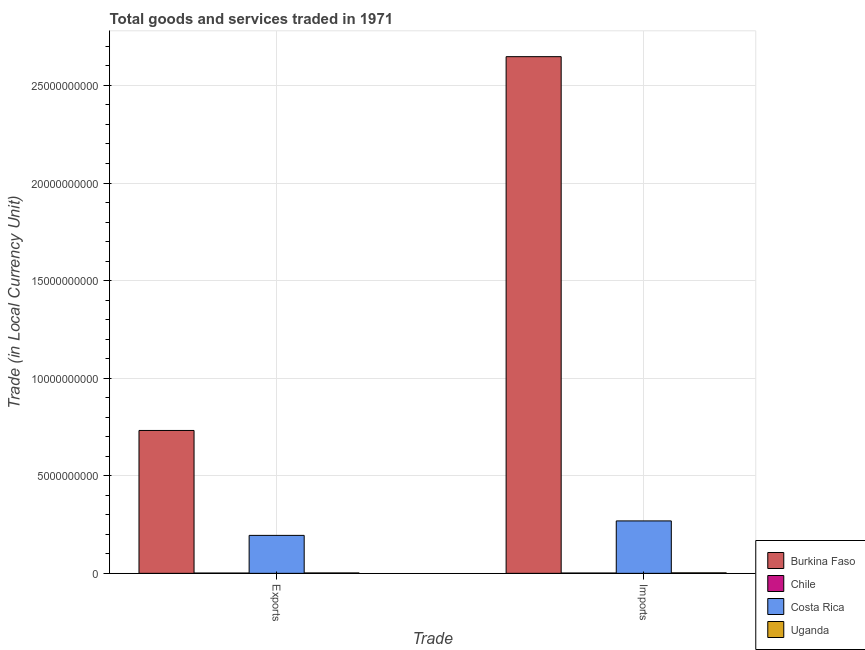How many groups of bars are there?
Provide a succinct answer. 2. Are the number of bars per tick equal to the number of legend labels?
Offer a very short reply. Yes. What is the label of the 1st group of bars from the left?
Make the answer very short. Exports. What is the export of goods and services in Chile?
Your response must be concise. 1.44e+07. Across all countries, what is the maximum imports of goods and services?
Offer a terse response. 2.65e+1. Across all countries, what is the minimum imports of goods and services?
Offer a very short reply. 1.57e+07. In which country was the imports of goods and services maximum?
Offer a terse response. Burkina Faso. In which country was the export of goods and services minimum?
Give a very brief answer. Chile. What is the total imports of goods and services in the graph?
Make the answer very short. 2.92e+1. What is the difference between the imports of goods and services in Chile and that in Costa Rica?
Make the answer very short. -2.67e+09. What is the difference between the imports of goods and services in Burkina Faso and the export of goods and services in Costa Rica?
Provide a short and direct response. 2.45e+1. What is the average imports of goods and services per country?
Give a very brief answer. 7.30e+09. What is the difference between the export of goods and services and imports of goods and services in Costa Rica?
Provide a short and direct response. -7.41e+08. What is the ratio of the export of goods and services in Costa Rica to that in Chile?
Provide a succinct answer. 135.07. In how many countries, is the imports of goods and services greater than the average imports of goods and services taken over all countries?
Your answer should be compact. 1. What does the 2nd bar from the left in Imports represents?
Your response must be concise. Chile. What does the 4th bar from the right in Exports represents?
Provide a succinct answer. Burkina Faso. Does the graph contain any zero values?
Give a very brief answer. No. How many legend labels are there?
Provide a short and direct response. 4. How are the legend labels stacked?
Keep it short and to the point. Vertical. What is the title of the graph?
Ensure brevity in your answer.  Total goods and services traded in 1971. Does "Lao PDR" appear as one of the legend labels in the graph?
Provide a short and direct response. No. What is the label or title of the X-axis?
Give a very brief answer. Trade. What is the label or title of the Y-axis?
Provide a succinct answer. Trade (in Local Currency Unit). What is the Trade (in Local Currency Unit) in Burkina Faso in Exports?
Make the answer very short. 7.32e+09. What is the Trade (in Local Currency Unit) in Chile in Exports?
Ensure brevity in your answer.  1.44e+07. What is the Trade (in Local Currency Unit) of Costa Rica in Exports?
Ensure brevity in your answer.  1.94e+09. What is the Trade (in Local Currency Unit) in Uganda in Exports?
Your answer should be compact. 2.01e+07. What is the Trade (in Local Currency Unit) of Burkina Faso in Imports?
Ensure brevity in your answer.  2.65e+1. What is the Trade (in Local Currency Unit) in Chile in Imports?
Provide a succinct answer. 1.57e+07. What is the Trade (in Local Currency Unit) in Costa Rica in Imports?
Offer a terse response. 2.69e+09. What is the Trade (in Local Currency Unit) of Uganda in Imports?
Ensure brevity in your answer.  2.42e+07. Across all Trade, what is the maximum Trade (in Local Currency Unit) of Burkina Faso?
Your response must be concise. 2.65e+1. Across all Trade, what is the maximum Trade (in Local Currency Unit) in Chile?
Offer a terse response. 1.57e+07. Across all Trade, what is the maximum Trade (in Local Currency Unit) of Costa Rica?
Your answer should be very brief. 2.69e+09. Across all Trade, what is the maximum Trade (in Local Currency Unit) of Uganda?
Make the answer very short. 2.42e+07. Across all Trade, what is the minimum Trade (in Local Currency Unit) of Burkina Faso?
Ensure brevity in your answer.  7.32e+09. Across all Trade, what is the minimum Trade (in Local Currency Unit) of Chile?
Your answer should be compact. 1.44e+07. Across all Trade, what is the minimum Trade (in Local Currency Unit) of Costa Rica?
Your answer should be compact. 1.94e+09. Across all Trade, what is the minimum Trade (in Local Currency Unit) of Uganda?
Give a very brief answer. 2.01e+07. What is the total Trade (in Local Currency Unit) in Burkina Faso in the graph?
Your answer should be very brief. 3.38e+1. What is the total Trade (in Local Currency Unit) in Chile in the graph?
Give a very brief answer. 3.01e+07. What is the total Trade (in Local Currency Unit) in Costa Rica in the graph?
Offer a terse response. 4.63e+09. What is the total Trade (in Local Currency Unit) of Uganda in the graph?
Give a very brief answer. 4.43e+07. What is the difference between the Trade (in Local Currency Unit) in Burkina Faso in Exports and that in Imports?
Ensure brevity in your answer.  -1.92e+1. What is the difference between the Trade (in Local Currency Unit) of Chile in Exports and that in Imports?
Ensure brevity in your answer.  -1.30e+06. What is the difference between the Trade (in Local Currency Unit) of Costa Rica in Exports and that in Imports?
Your response must be concise. -7.41e+08. What is the difference between the Trade (in Local Currency Unit) of Uganda in Exports and that in Imports?
Your response must be concise. -4.19e+06. What is the difference between the Trade (in Local Currency Unit) of Burkina Faso in Exports and the Trade (in Local Currency Unit) of Chile in Imports?
Provide a short and direct response. 7.31e+09. What is the difference between the Trade (in Local Currency Unit) in Burkina Faso in Exports and the Trade (in Local Currency Unit) in Costa Rica in Imports?
Give a very brief answer. 4.63e+09. What is the difference between the Trade (in Local Currency Unit) of Burkina Faso in Exports and the Trade (in Local Currency Unit) of Uganda in Imports?
Your answer should be compact. 7.30e+09. What is the difference between the Trade (in Local Currency Unit) in Chile in Exports and the Trade (in Local Currency Unit) in Costa Rica in Imports?
Your response must be concise. -2.67e+09. What is the difference between the Trade (in Local Currency Unit) in Chile in Exports and the Trade (in Local Currency Unit) in Uganda in Imports?
Offer a very short reply. -9.85e+06. What is the difference between the Trade (in Local Currency Unit) in Costa Rica in Exports and the Trade (in Local Currency Unit) in Uganda in Imports?
Offer a very short reply. 1.92e+09. What is the average Trade (in Local Currency Unit) of Burkina Faso per Trade?
Your response must be concise. 1.69e+1. What is the average Trade (in Local Currency Unit) of Chile per Trade?
Keep it short and to the point. 1.50e+07. What is the average Trade (in Local Currency Unit) in Costa Rica per Trade?
Offer a terse response. 2.32e+09. What is the average Trade (in Local Currency Unit) of Uganda per Trade?
Offer a terse response. 2.22e+07. What is the difference between the Trade (in Local Currency Unit) in Burkina Faso and Trade (in Local Currency Unit) in Chile in Exports?
Ensure brevity in your answer.  7.31e+09. What is the difference between the Trade (in Local Currency Unit) of Burkina Faso and Trade (in Local Currency Unit) of Costa Rica in Exports?
Keep it short and to the point. 5.38e+09. What is the difference between the Trade (in Local Currency Unit) of Burkina Faso and Trade (in Local Currency Unit) of Uganda in Exports?
Your answer should be compact. 7.30e+09. What is the difference between the Trade (in Local Currency Unit) in Chile and Trade (in Local Currency Unit) in Costa Rica in Exports?
Keep it short and to the point. -1.93e+09. What is the difference between the Trade (in Local Currency Unit) of Chile and Trade (in Local Currency Unit) of Uganda in Exports?
Provide a short and direct response. -5.66e+06. What is the difference between the Trade (in Local Currency Unit) in Costa Rica and Trade (in Local Currency Unit) in Uganda in Exports?
Offer a terse response. 1.92e+09. What is the difference between the Trade (in Local Currency Unit) in Burkina Faso and Trade (in Local Currency Unit) in Chile in Imports?
Offer a terse response. 2.65e+1. What is the difference between the Trade (in Local Currency Unit) in Burkina Faso and Trade (in Local Currency Unit) in Costa Rica in Imports?
Offer a terse response. 2.38e+1. What is the difference between the Trade (in Local Currency Unit) of Burkina Faso and Trade (in Local Currency Unit) of Uganda in Imports?
Make the answer very short. 2.65e+1. What is the difference between the Trade (in Local Currency Unit) in Chile and Trade (in Local Currency Unit) in Costa Rica in Imports?
Provide a short and direct response. -2.67e+09. What is the difference between the Trade (in Local Currency Unit) of Chile and Trade (in Local Currency Unit) of Uganda in Imports?
Ensure brevity in your answer.  -8.55e+06. What is the difference between the Trade (in Local Currency Unit) of Costa Rica and Trade (in Local Currency Unit) of Uganda in Imports?
Your response must be concise. 2.66e+09. What is the ratio of the Trade (in Local Currency Unit) of Burkina Faso in Exports to that in Imports?
Your answer should be compact. 0.28. What is the ratio of the Trade (in Local Currency Unit) of Chile in Exports to that in Imports?
Offer a terse response. 0.92. What is the ratio of the Trade (in Local Currency Unit) of Costa Rica in Exports to that in Imports?
Your response must be concise. 0.72. What is the ratio of the Trade (in Local Currency Unit) of Uganda in Exports to that in Imports?
Keep it short and to the point. 0.83. What is the difference between the highest and the second highest Trade (in Local Currency Unit) in Burkina Faso?
Keep it short and to the point. 1.92e+1. What is the difference between the highest and the second highest Trade (in Local Currency Unit) in Chile?
Offer a very short reply. 1.30e+06. What is the difference between the highest and the second highest Trade (in Local Currency Unit) of Costa Rica?
Offer a terse response. 7.41e+08. What is the difference between the highest and the second highest Trade (in Local Currency Unit) in Uganda?
Provide a succinct answer. 4.19e+06. What is the difference between the highest and the lowest Trade (in Local Currency Unit) of Burkina Faso?
Keep it short and to the point. 1.92e+1. What is the difference between the highest and the lowest Trade (in Local Currency Unit) in Chile?
Provide a short and direct response. 1.30e+06. What is the difference between the highest and the lowest Trade (in Local Currency Unit) of Costa Rica?
Offer a terse response. 7.41e+08. What is the difference between the highest and the lowest Trade (in Local Currency Unit) in Uganda?
Offer a very short reply. 4.19e+06. 